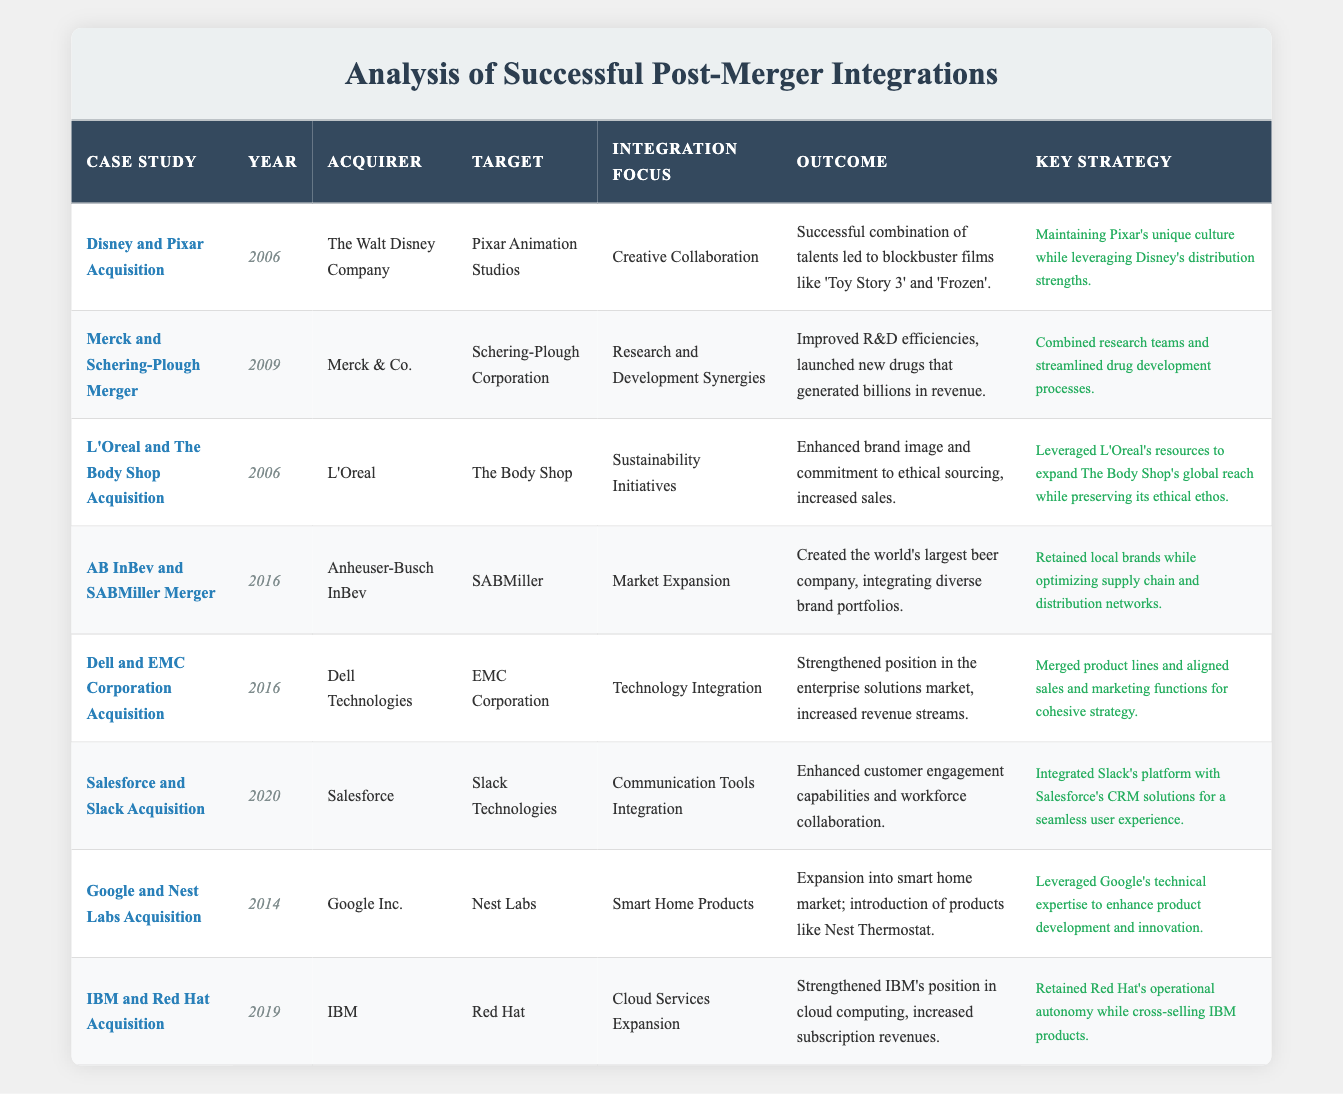What year did the Disney and Pixar acquisition take place? The table lists "Disney and Pixar Acquisition" under the "Case Study" column, and the corresponding year value is 2006 in the "Year" column.
Answer: 2006 Which company was the acquirer in the Merck and Schering-Plough merger? According to the table, the acquirer for the "Merck and Schering-Plough Merger" case study is "Merck & Co." found in the "Acquirer" column.
Answer: Merck & Co True or False: The key strategy for the acquisition of Slack by Salesforce involved maintaining Slack's operational autonomy. The table under the "Key Strategy" column for the "Salesforce and Slack Acquisition" states it integrated Slack's platform with Salesforce's CRM solutions, indicating it did not focus on maintaining autonomy, hence the answer is false.
Answer: False What was the main integration focus for the Google and Nest Labs acquisition? By referring to the entry for "Google and Nest Labs Acquisition," the "Integration Focus" column shows that the main focus was "Smart Home Products."
Answer: Smart Home Products Calculate the total number of case studies listed in the table. To find the total, we can count the number of entries under the "Case Study" column. There are 8 case studies listed in total.
Answer: 8 What was the outcome of the merger between AB InBev and SABMiller? The outcome for the "AB InBev and SABMiller Merger" is noted in the "Outcome" column as "Created the world's largest beer company, integrating diverse brand portfolios."
Answer: Created the world's largest beer company Which two companies merged in 2019? Checking the "Year" column for 2019 indicates that the merger involved "IBM" as the acquirer and "Red Hat" as the target, listed under the "Acquirer" and "Target" columns.
Answer: IBM and Red Hat True or False: The key strategy for the L'Oreal and The Body Shop acquisition emphasized complete integration of L'Oreal's operational processes. The "Key Strategy" for the "L'Oreal and The Body Shop Acquisition" notes preserving The Body Shop's ethical ethos, indicating a partial integration rather than complete. Therefore, the answer is false.
Answer: False What year did the acquisition of Slack by Salesforce occur? By looking at the "Salesforce and Slack Acquisition" entry in the table, the "Year" column indicates it happened in 2020.
Answer: 2020 